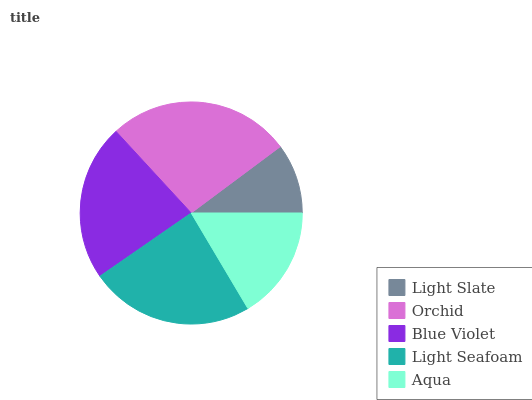Is Light Slate the minimum?
Answer yes or no. Yes. Is Orchid the maximum?
Answer yes or no. Yes. Is Blue Violet the minimum?
Answer yes or no. No. Is Blue Violet the maximum?
Answer yes or no. No. Is Orchid greater than Blue Violet?
Answer yes or no. Yes. Is Blue Violet less than Orchid?
Answer yes or no. Yes. Is Blue Violet greater than Orchid?
Answer yes or no. No. Is Orchid less than Blue Violet?
Answer yes or no. No. Is Blue Violet the high median?
Answer yes or no. Yes. Is Blue Violet the low median?
Answer yes or no. Yes. Is Light Seafoam the high median?
Answer yes or no. No. Is Light Slate the low median?
Answer yes or no. No. 